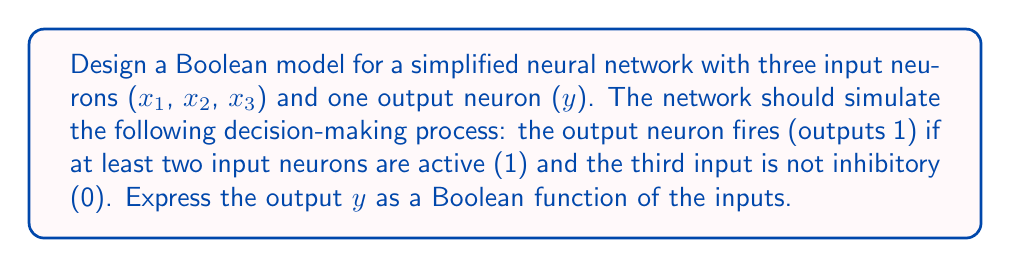Can you solve this math problem? Let's approach this step-by-step:

1) First, we need to identify the conditions for the output neuron to fire:
   - At least two input neurons are active (1)
   - The third input is not inhibitory (0)

2) We can express this using Boolean algebra as follows:
   $y = (x_1 \land x_2 \land \neg x_3) \lor (x_1 \land \neg x_2 \land x_3) \lor (\neg x_1 \land x_2 \land x_3) \lor (x_1 \land x_2 \land x_3)$

3) Let's break this down:
   - $(x_1 \land x_2 \land \neg x_3)$: $x_1$ and $x_2$ are active, $x_3$ is not
   - $(x_1 \land \neg x_2 \land x_3)$: $x_1$ and $x_3$ are active, $x_2$ is not
   - $(\neg x_1 \land x_2 \land x_3)$: $x_2$ and $x_3$ are active, $x_1$ is not
   - $(x_1 \land x_2 \land x_3)$: all inputs are active

4) We can simplify this expression using Boolean algebra laws:
   $y = (x_1 \land x_2) \lor (x_1 \land x_3) \lor (x_2 \land x_3)$

5) This simplified expression represents the majority function for three inputs, which is exactly what we need: the output is 1 if at least two inputs are 1.

6) We can verify that this function satisfies our requirements:
   - It outputs 1 when any two or more inputs are 1
   - It outputs 0 when two or more inputs are 0

7) This Boolean function effectively simulates our simplified neural network's decision-making process.
Answer: $y = (x_1 \land x_2) \lor (x_1 \land x_3) \lor (x_2 \land x_3)$ 